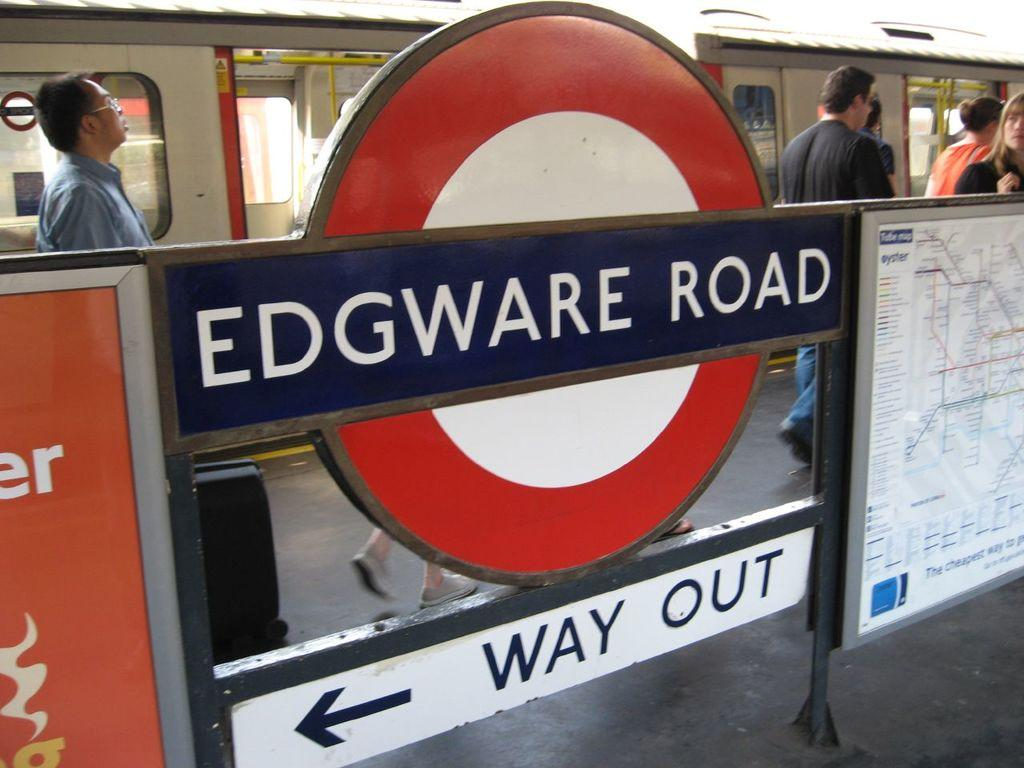Who or what can be seen in the image? There are people in the image. What is the main object in the background? There is a train in the image. What is on the board in the image? A: There is a map on the board in the image. Is there any text or writing on the board? Yes, there is writing on the board in the image. What type of harmony can be heard in the image? There is no audible sound in the image, so it is not possible to determine if any harmony can be heard. 